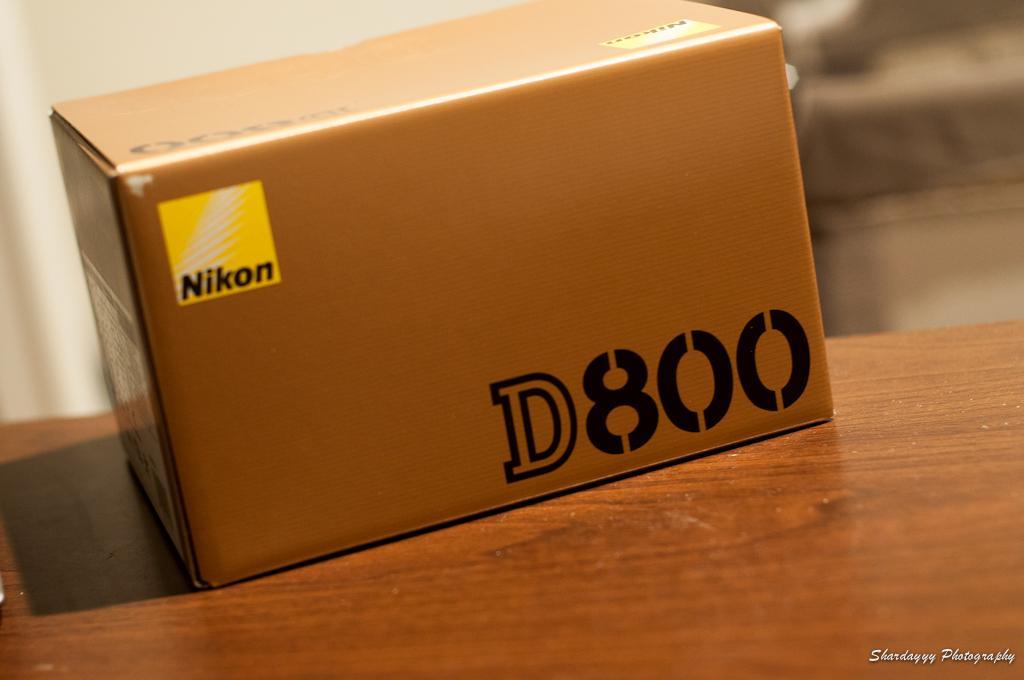How would you summarize this image in a sentence or two? In the foreground of this image, there is a cardboard box on a wooden surface and the background image is blur. 